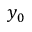<formula> <loc_0><loc_0><loc_500><loc_500>y _ { 0 }</formula> 